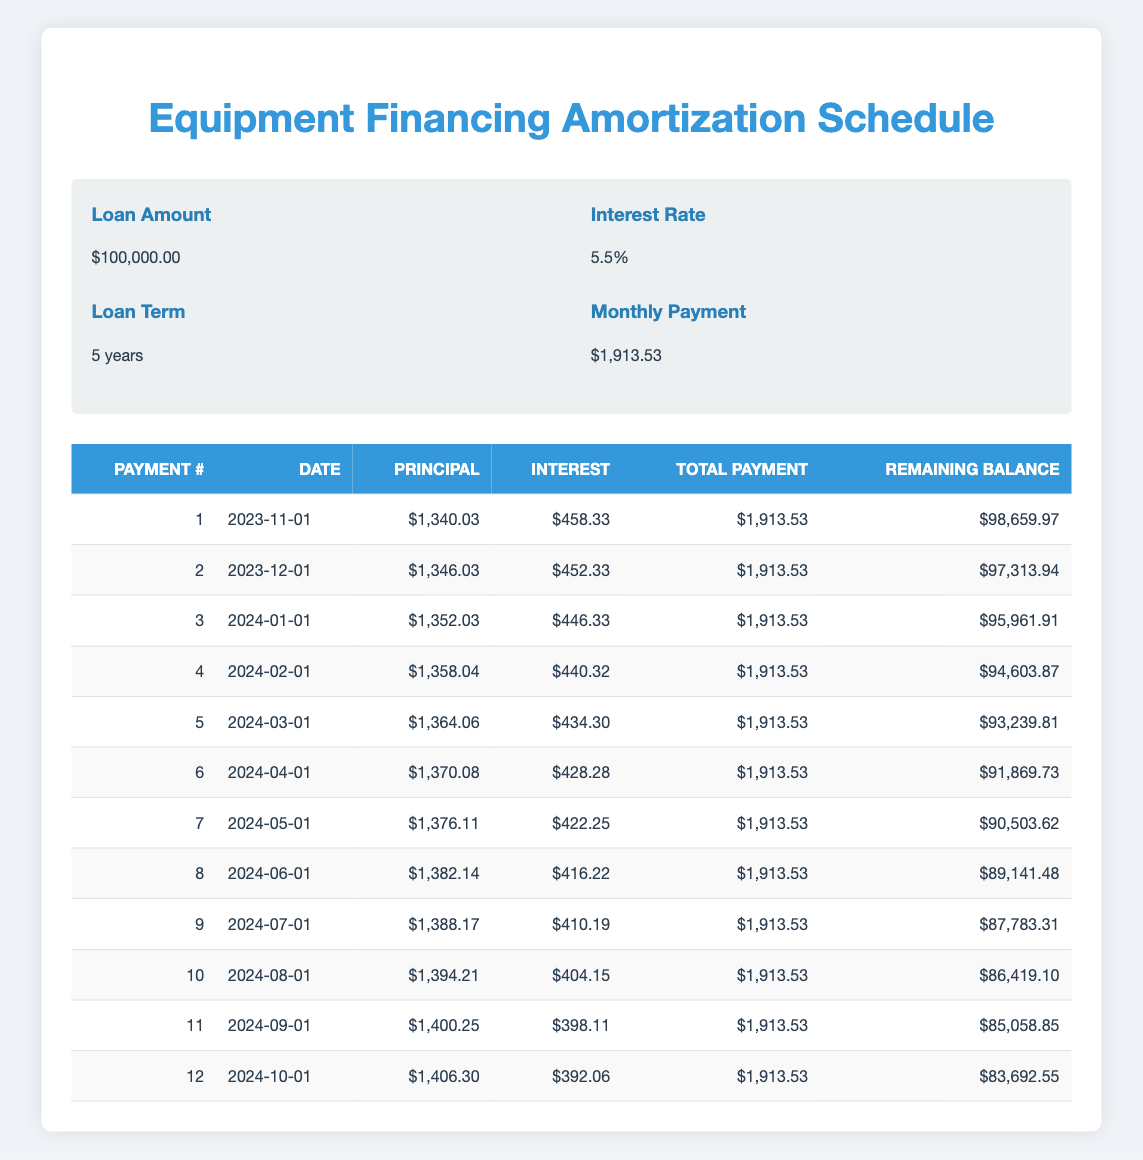What is the total payment amount for the first month? The total payment for the first month is directly stated in the table under the "Total Payment" column for Payment #1, which is $1,913.53.
Answer: 1913.53 How much of the third payment goes toward the principal? The amount going towards the principal for the third payment is available in the "Principal" column for Payment #3, which shows $1,352.03.
Answer: 1352.03 Is the interest payment for the second month less than the first month? To determine this, compare the interest payments for Payment #1 and Payment #2. Payment #1 has an interest payment of $458.33 and Payment #2 has $452.33, which shows that the second month’s interest payment is indeed lower.
Answer: Yes What is the remaining balance after the sixth payment? The remaining balance is shown in the table under the "Remaining Balance" column for Payment #6, which is $91,869.73.
Answer: 91869.73 Calculate the total amount paid in the first year of the loan. To calculate the total amount paid in the first year, sum the total payments from Payment #1 to Payment #12 (for the first 12 months). This would be 12 payments of $1,913.53: 12 x 1,913.53 = $22,962.36.
Answer: 22962.36 What is the average principal payment over the first six months? The principal payments for the first six months are $1,340.03, $1,346.03, $1,352.03, $1,358.04, $1,364.06, and $1,370.08. Add them together: 1,340.03 + 1,346.03 + 1,352.03 + 1,358.04 + 1,364.06 + 1,370.08 = $8,130.27. Divide this total by 6: $8,130.27 / 6 = $1,355.05.
Answer: 1355.05 Is the interest payment for the last payment lower than the average interest payment of the first half of the loan repayments? The interest payment for the last payment (Payment #12) is $392.06. The average interest payment for the first six payments ((458.33 + 452.33 + 446.33 + 440.32 + 434.30 + 428.28) / 6) is $454.32. Since $392.06 is less than $454.32, the answer is yes.
Answer: Yes What is the total amount of principal paid off after the first three payments? To find the total amount of principal paid off after the first three payments, sum the principal payments for Payment #1, Payment #2, and Payment #3: $1,340.03 + $1,346.03 + $1,352.03 = $4,038.09.
Answer: 4038.09 How much interest will be paid in the fourth month? The interest payment for the fourth month is directly listed in the "Interest" column for Payment #4, which is $440.32.
Answer: 440.32 